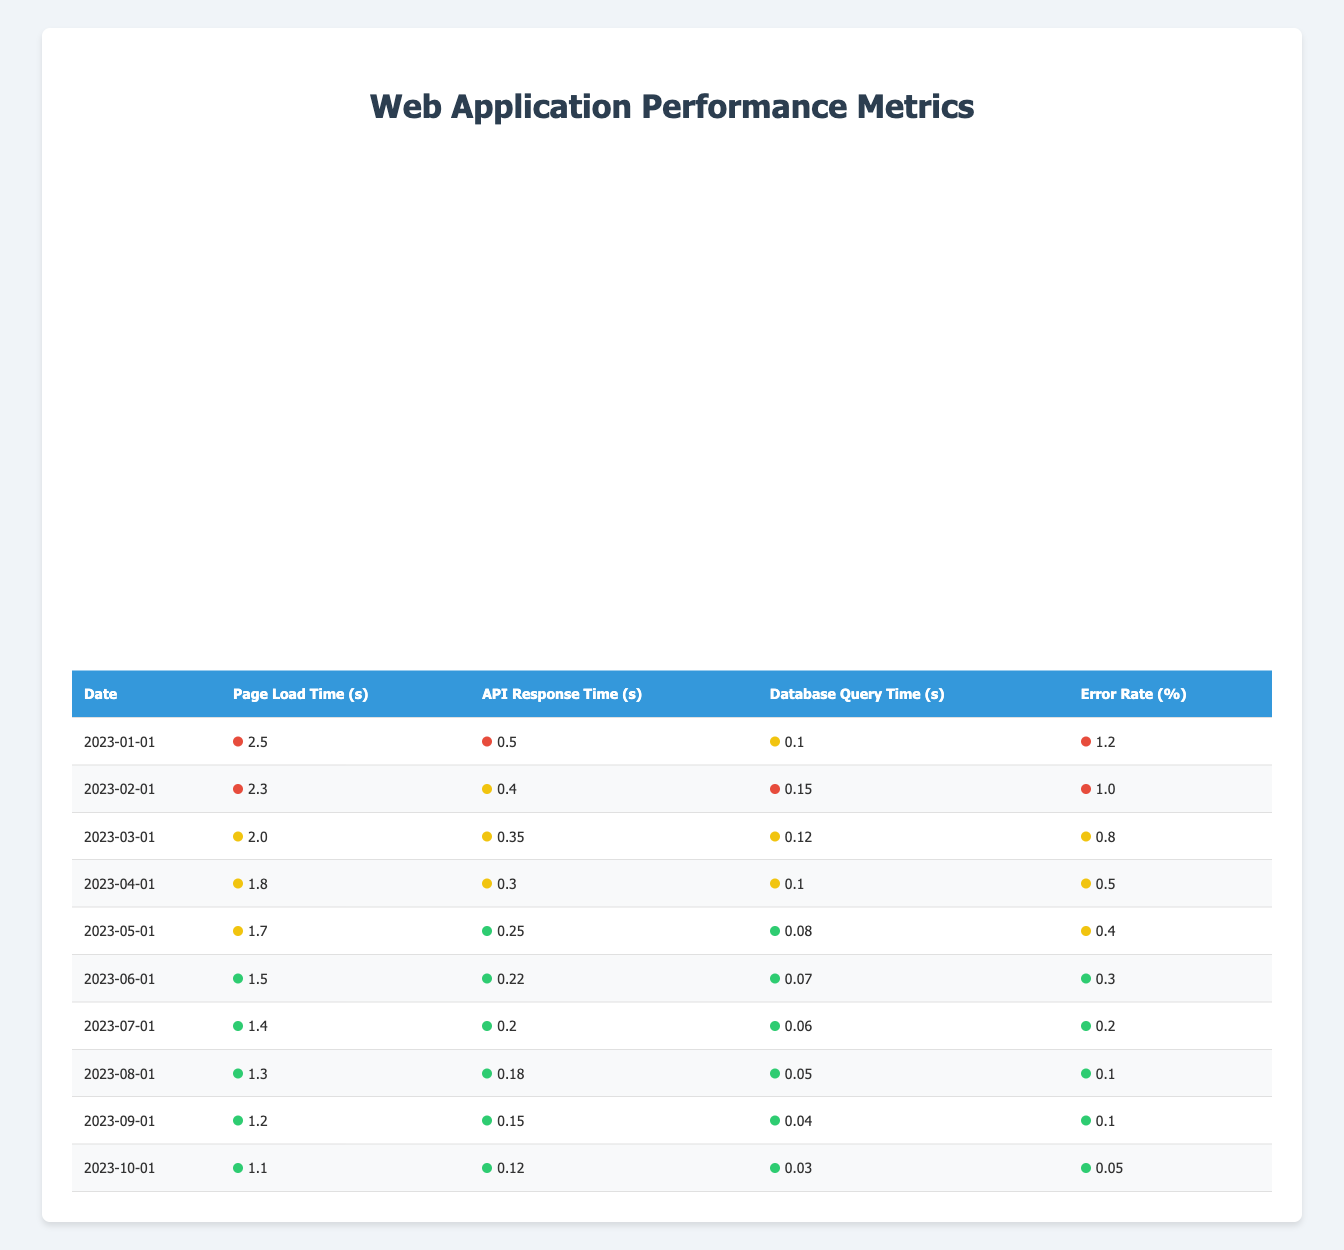What is the page load time on 2023-10-01? The table shows the "Page Load Time (s)" for "2023-10-01" is 1.1 seconds in the corresponding row.
Answer: 1.1 What is the error rate for March 2023? Looking at the row for "2023-03-01," the "Error Rate (%)" is listed as 0.8 percent.
Answer: 0.8 What was the average API response time over the first three months of 2023? The API response times for January, February, and March are 0.5, 0.4, and 0.35 seconds respectively. To find the average, sum them up: 0.5 + 0.4 + 0.35 = 1.25 seconds. Then, divide by 3, which gives us 1.25 / 3 = approximately 0.4167 seconds.
Answer: 0.4167 Was there a decrease in database query time from January to October 2023? The database query times for January and October are 0.1 seconds and 0.03 seconds respectively. Since 0.1 is greater than 0.03, it indicates a decrease.
Answer: Yes What is the trend of error rates from January to October 2023? Analyzing the error rates from the table: 1.2, 1.0, 0.8, 0.5, 0.4, 0.3, 0.2, 0.1, and 0.05. By reviewing these values, we can see consistently decreasing values over time. This indicates a downward trend.
Answer: Decreasing trend What was the fastest API response time recorded during the above months? The lowest value listed for API response time in the table is 0.12 seconds on "2023-10-01."
Answer: 0.12 What was the change in page load time from January to August 2023? The page load time in January was 2.5 seconds and in August it was 1.3 seconds. The change can be calculated as 2.5 - 1.3 = 1.2 seconds, indicating a decrease in load time.
Answer: 1.2 seconds Which month had the lowest error rate, and what was that rate? The month with the lowest error rate is "2023-10-01," where the error rate is reported as 0.05 percent, which is lower than all other months listed in the table.
Answer: 2023-10-01, 0.05 What is the difference between the highest and lowest values of database query time? The highest database query time recorded in January is 0.1 seconds, and the lowest recorded in October is 0.03 seconds. The difference is calculated by subtracting the lowest value from the highest: 0.1 - 0.03 = 0.07 seconds.
Answer: 0.07 seconds 